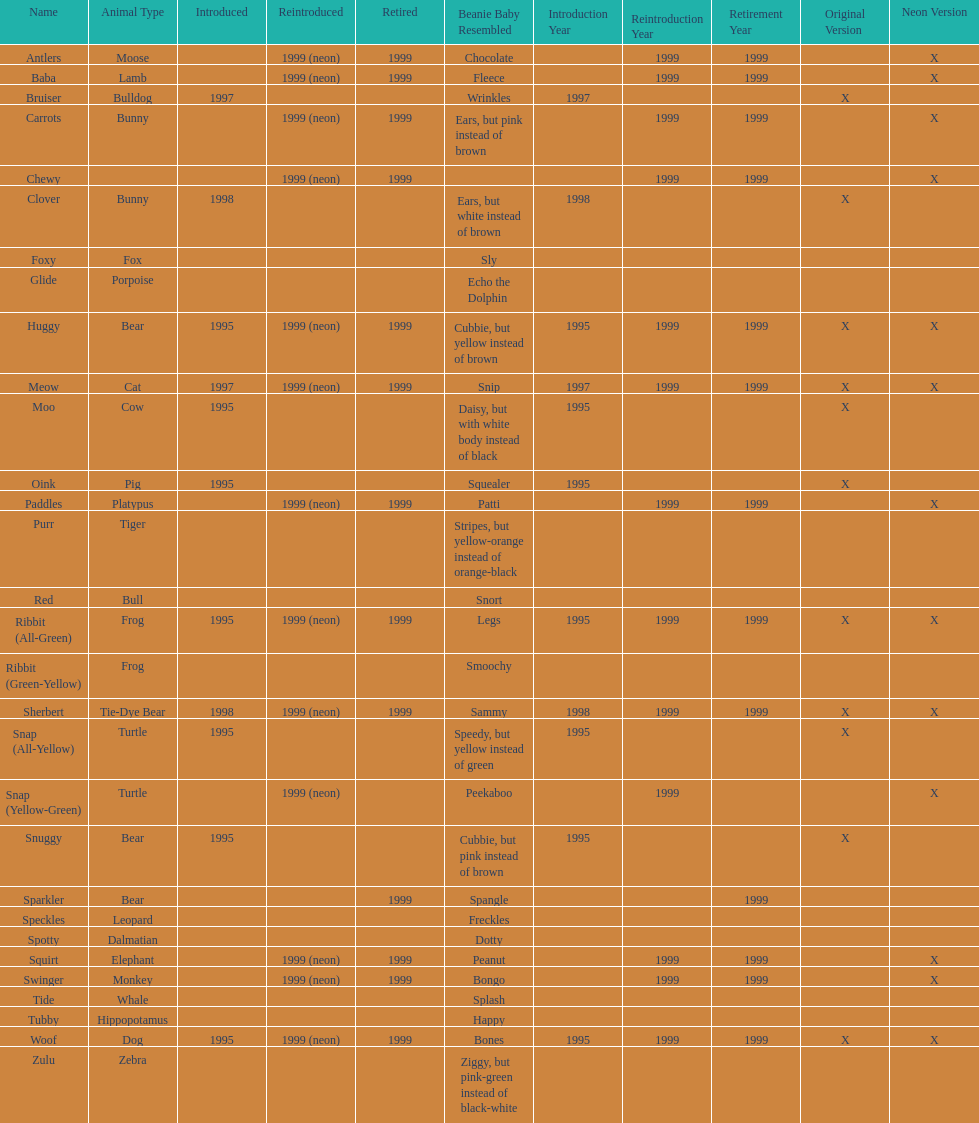How many monkey pillow pals were there? 1. 